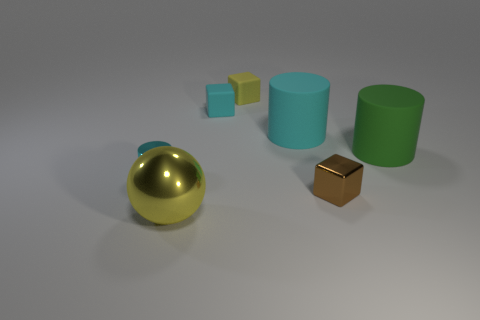Subtract 1 blocks. How many blocks are left? 2 Add 2 tiny brown objects. How many objects exist? 9 Subtract all small cyan matte blocks. Subtract all tiny cyan cylinders. How many objects are left? 5 Add 3 tiny brown shiny objects. How many tiny brown shiny objects are left? 4 Add 7 cylinders. How many cylinders exist? 10 Subtract 0 purple spheres. How many objects are left? 7 Subtract all cubes. How many objects are left? 4 